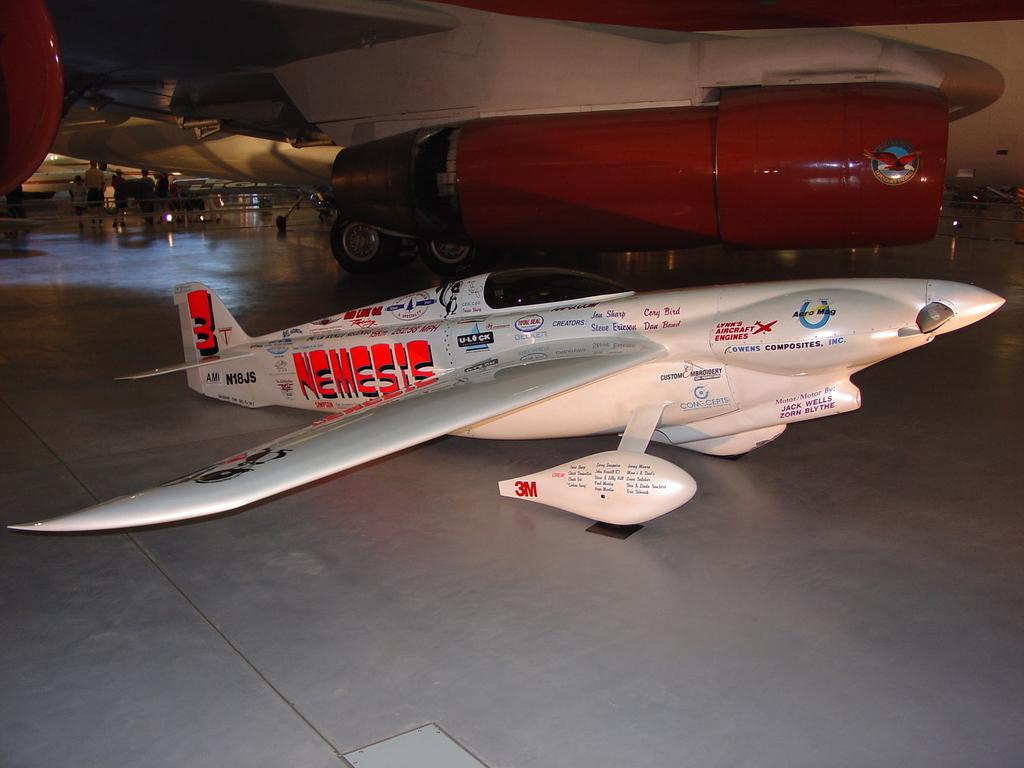What is the main subject of the image? The main subjects of the image are an aircraft and an airplane. Can you describe the setting of the image? The persons in the image are standing inside a hangar. What else can be seen in the background of the image? There are persons standing in the background of the image. What type of toothbrush is being used by the person in the image? There is no toothbrush present in the image. Can you describe the hand gestures of the person in the image? The image does not show any hand gestures; it only shows the persons standing inside a hangar. 